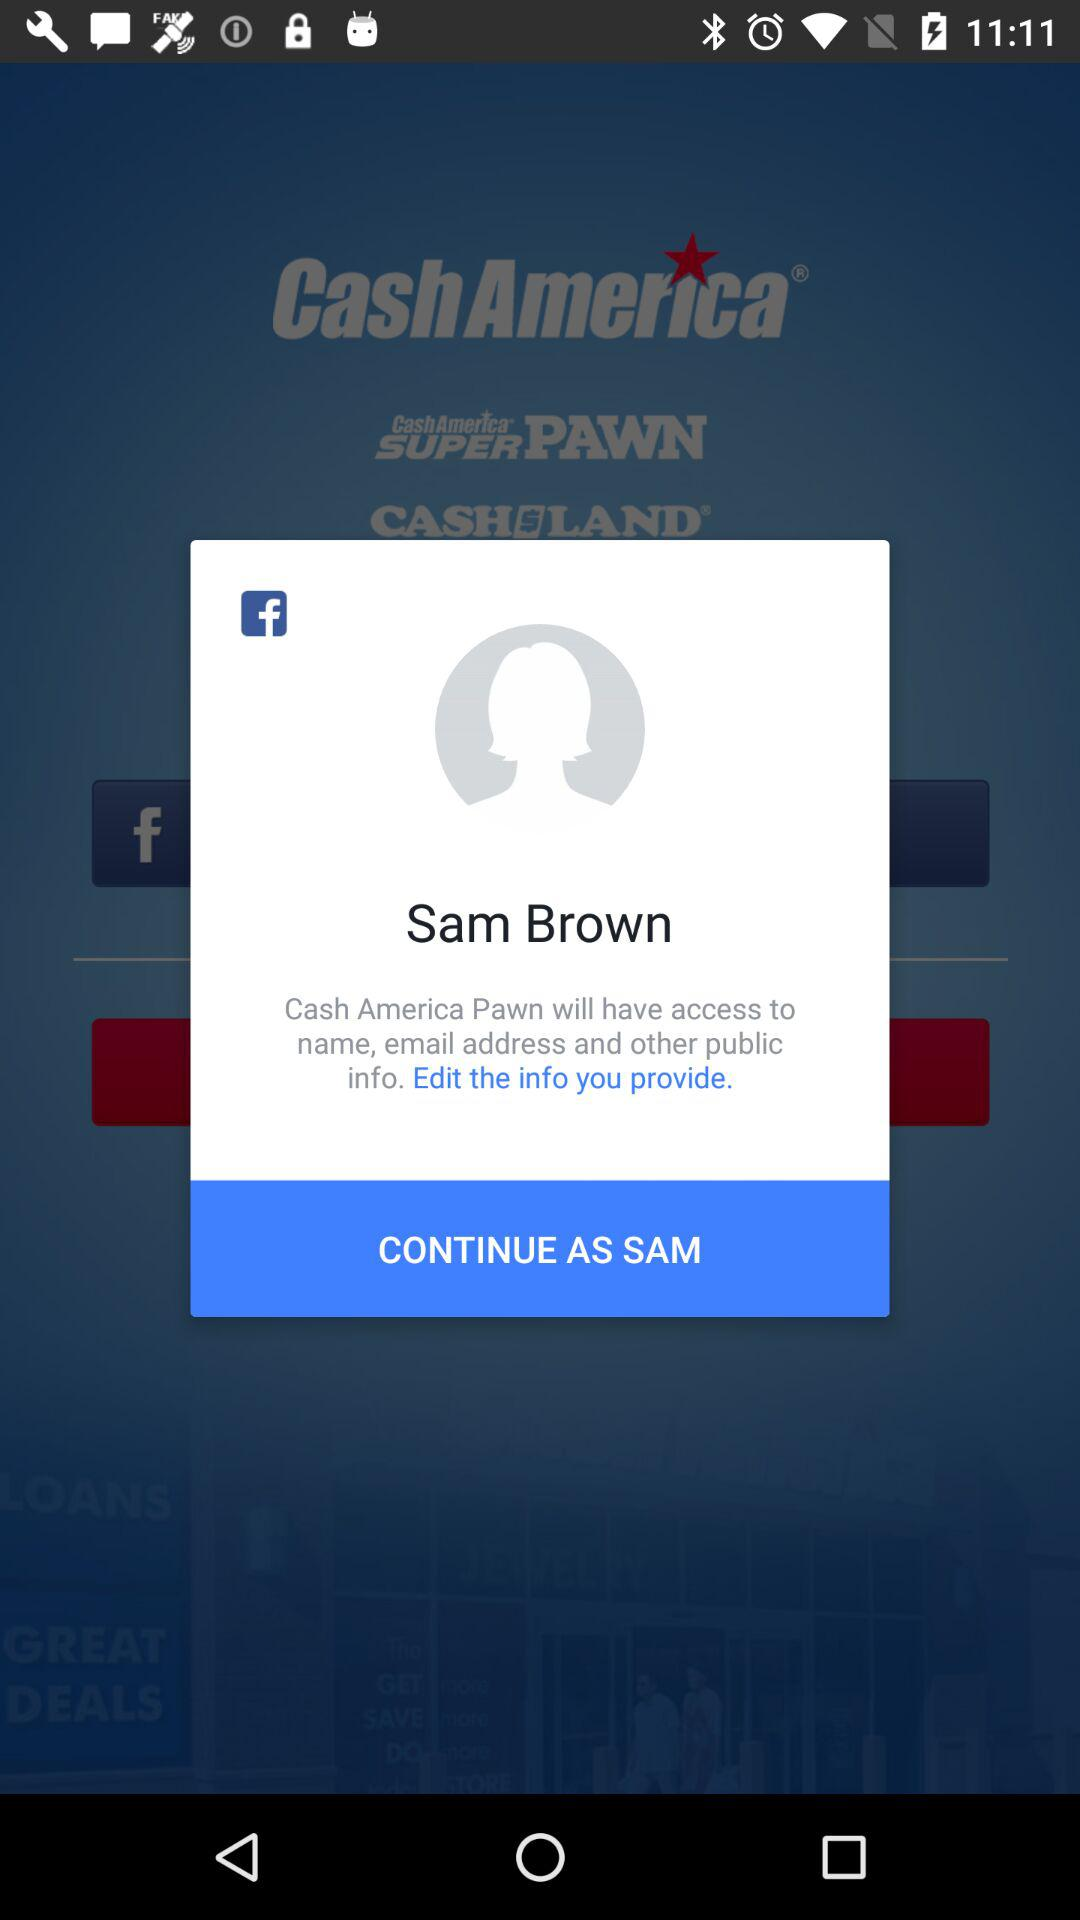What application is asking for permission? The application asking for permission is "Cash America Pawn". 